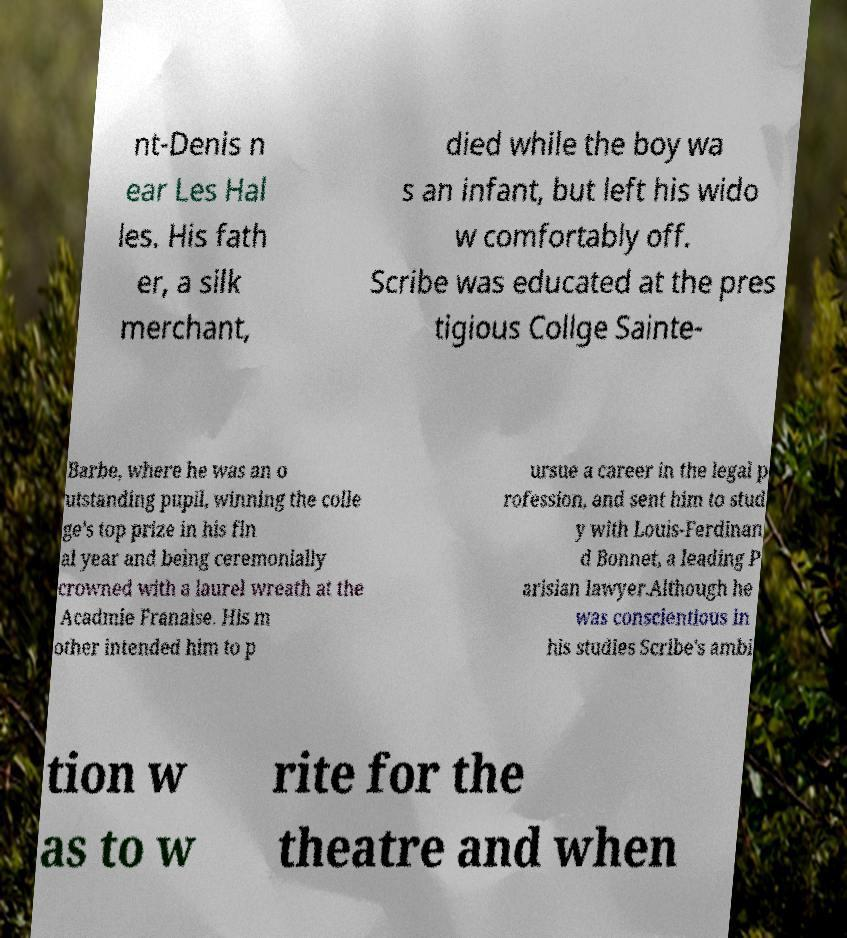There's text embedded in this image that I need extracted. Can you transcribe it verbatim? nt-Denis n ear Les Hal les. His fath er, a silk merchant, died while the boy wa s an infant, but left his wido w comfortably off. Scribe was educated at the pres tigious Collge Sainte- Barbe, where he was an o utstanding pupil, winning the colle ge's top prize in his fin al year and being ceremonially crowned with a laurel wreath at the Acadmie Franaise. His m other intended him to p ursue a career in the legal p rofession, and sent him to stud y with Louis-Ferdinan d Bonnet, a leading P arisian lawyer.Although he was conscientious in his studies Scribe's ambi tion w as to w rite for the theatre and when 